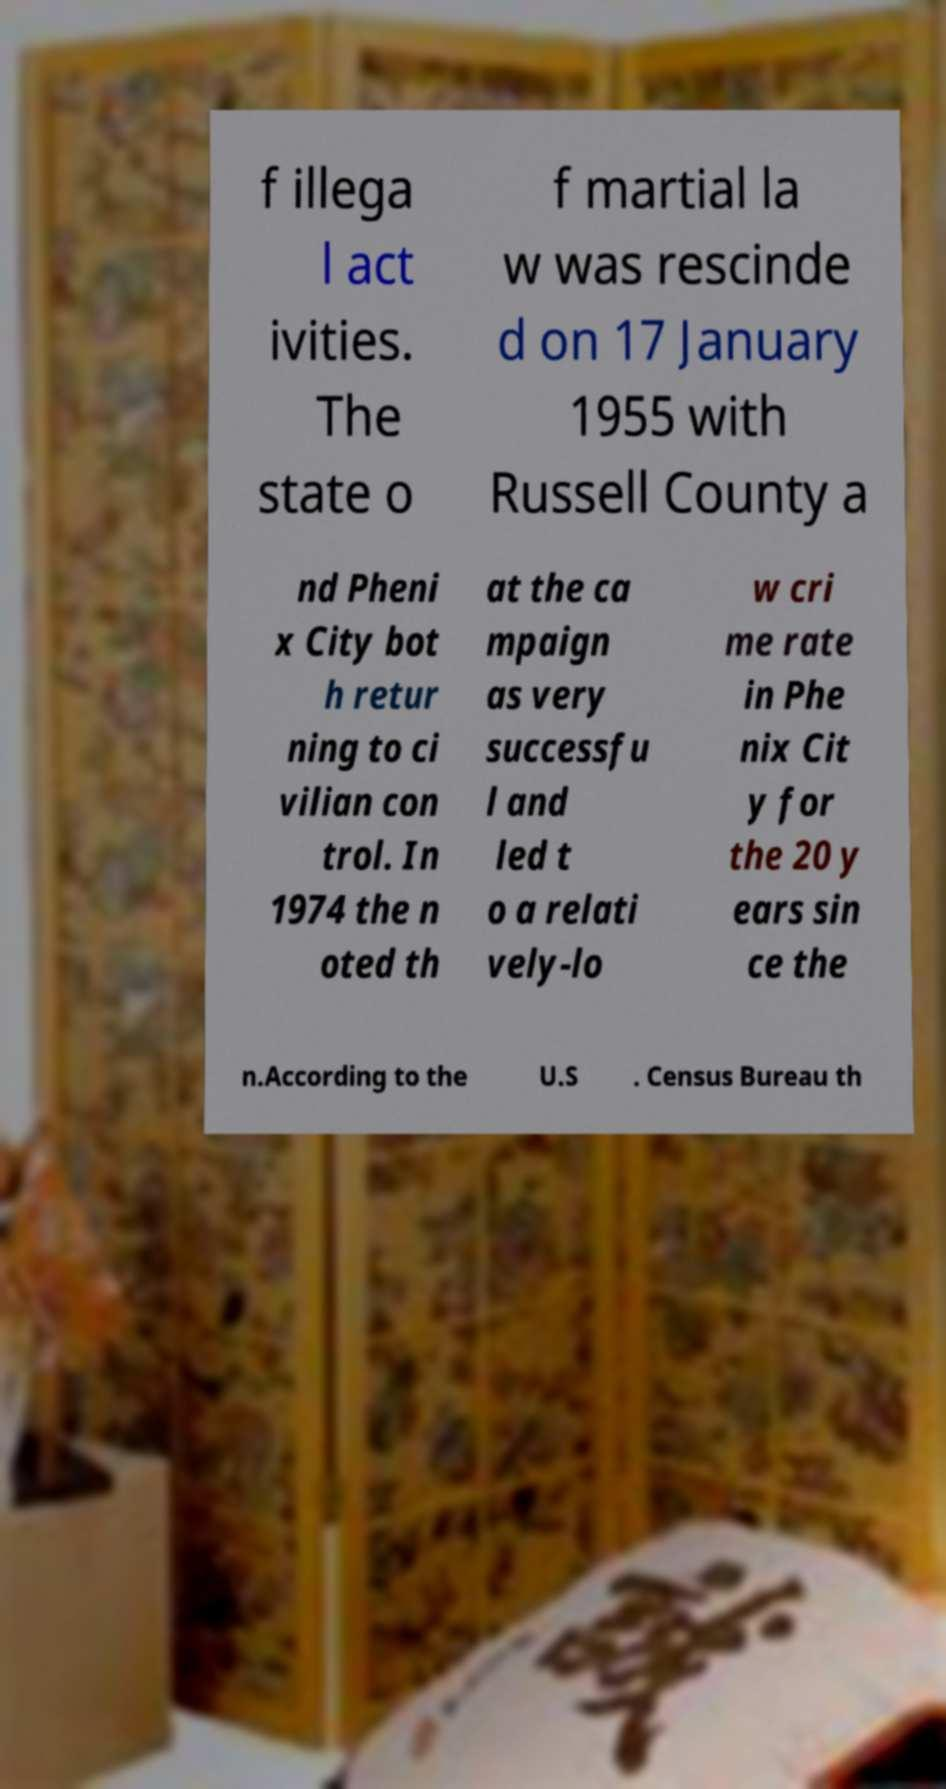Please identify and transcribe the text found in this image. f illega l act ivities. The state o f martial la w was rescinde d on 17 January 1955 with Russell County a nd Pheni x City bot h retur ning to ci vilian con trol. In 1974 the n oted th at the ca mpaign as very successfu l and led t o a relati vely-lo w cri me rate in Phe nix Cit y for the 20 y ears sin ce the n.According to the U.S . Census Bureau th 